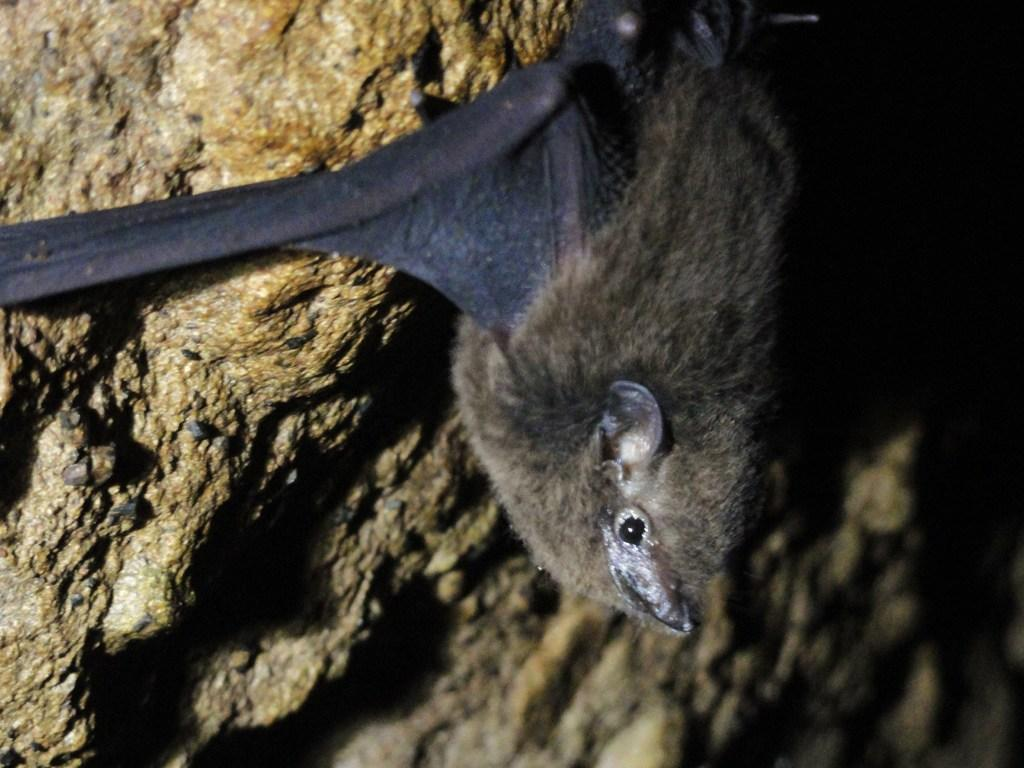What animal is present in the image? There is a bat in the image. Where is the bat located? The bat is hanging on a stone wall. What color is the bat's toe in the image? There is no mention of the bat's toe in the provided facts, and it is not visible in the image. 